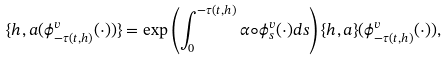<formula> <loc_0><loc_0><loc_500><loc_500>\{ h , a ( \phi ^ { v } _ { - \tau ( t , h ) } ( \cdot ) ) \} = \exp \left ( \int ^ { - \tau ( t , h ) } _ { 0 } \alpha \circ \phi ^ { v } _ { s } ( \cdot ) d s \right ) \{ h , a \} ( \phi ^ { v } _ { - \tau ( t , h ) } ( \cdot ) ) ,</formula> 